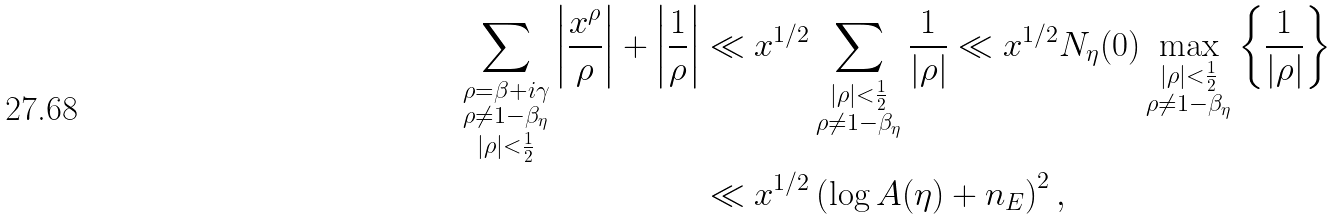<formula> <loc_0><loc_0><loc_500><loc_500>\sum _ { \substack { \rho = \beta + i \gamma \\ \rho \ne 1 - \beta _ { \eta } \\ | \rho | < \frac { 1 } { 2 } } } \left | \frac { x ^ { \rho } } { \rho } \right | + \left | \frac { 1 } { \rho } \right | & \ll x ^ { 1 / 2 } \sum _ { \substack { | \rho | < \frac { 1 } { 2 } \\ \rho \ne 1 - \beta _ { \eta } } } \frac { 1 } { | \rho | } \ll x ^ { 1 / 2 } N _ { \eta } ( 0 ) \max _ { \substack { | \rho | < \frac { 1 } { 2 } \\ \rho \ne 1 - \beta _ { \eta } } } \left \{ \frac { 1 } { | \rho | } \right \} \\ & \ll x ^ { 1 / 2 } \left ( \log A ( \eta ) + n _ { E } \right ) ^ { 2 } ,</formula> 